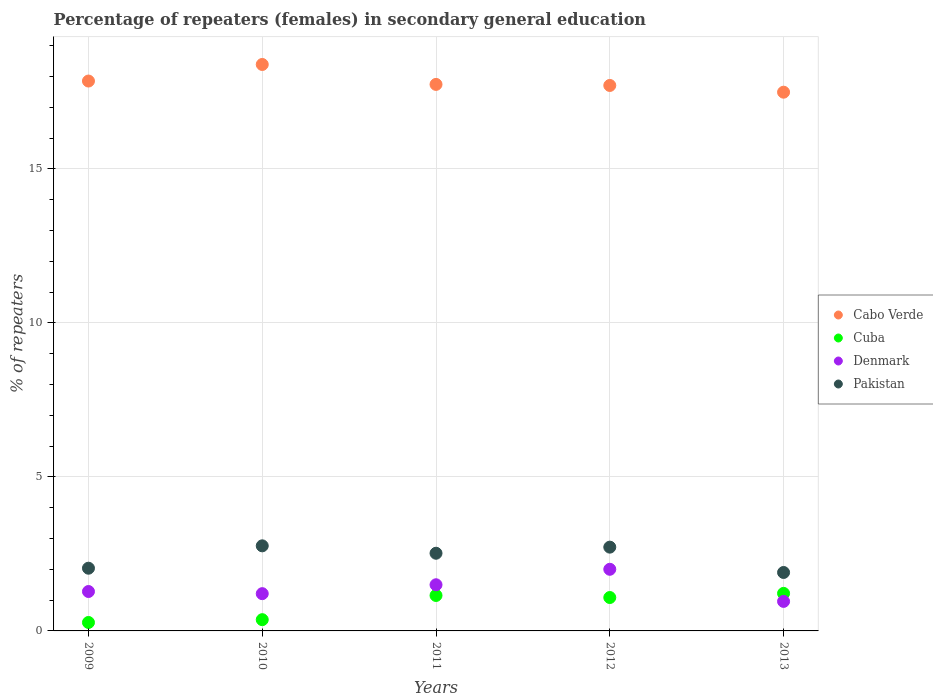Is the number of dotlines equal to the number of legend labels?
Ensure brevity in your answer.  Yes. What is the percentage of female repeaters in Cuba in 2011?
Provide a short and direct response. 1.15. Across all years, what is the maximum percentage of female repeaters in Cuba?
Give a very brief answer. 1.22. Across all years, what is the minimum percentage of female repeaters in Cabo Verde?
Make the answer very short. 17.49. In which year was the percentage of female repeaters in Denmark maximum?
Your answer should be very brief. 2012. In which year was the percentage of female repeaters in Cuba minimum?
Make the answer very short. 2009. What is the total percentage of female repeaters in Pakistan in the graph?
Your response must be concise. 11.94. What is the difference between the percentage of female repeaters in Pakistan in 2009 and that in 2012?
Your answer should be very brief. -0.68. What is the difference between the percentage of female repeaters in Cuba in 2013 and the percentage of female repeaters in Denmark in 2012?
Offer a very short reply. -0.78. What is the average percentage of female repeaters in Cuba per year?
Offer a very short reply. 0.82. In the year 2010, what is the difference between the percentage of female repeaters in Denmark and percentage of female repeaters in Pakistan?
Offer a terse response. -1.55. What is the ratio of the percentage of female repeaters in Cabo Verde in 2010 to that in 2011?
Make the answer very short. 1.04. What is the difference between the highest and the second highest percentage of female repeaters in Pakistan?
Give a very brief answer. 0.04. What is the difference between the highest and the lowest percentage of female repeaters in Cabo Verde?
Your answer should be very brief. 0.9. In how many years, is the percentage of female repeaters in Denmark greater than the average percentage of female repeaters in Denmark taken over all years?
Your answer should be compact. 2. Is it the case that in every year, the sum of the percentage of female repeaters in Cuba and percentage of female repeaters in Pakistan  is greater than the percentage of female repeaters in Cabo Verde?
Offer a terse response. No. Does the percentage of female repeaters in Pakistan monotonically increase over the years?
Your answer should be compact. No. How many dotlines are there?
Provide a short and direct response. 4. Does the graph contain any zero values?
Your answer should be compact. No. How are the legend labels stacked?
Make the answer very short. Vertical. What is the title of the graph?
Keep it short and to the point. Percentage of repeaters (females) in secondary general education. Does "Myanmar" appear as one of the legend labels in the graph?
Offer a terse response. No. What is the label or title of the X-axis?
Keep it short and to the point. Years. What is the label or title of the Y-axis?
Make the answer very short. % of repeaters. What is the % of repeaters in Cabo Verde in 2009?
Provide a succinct answer. 17.85. What is the % of repeaters of Cuba in 2009?
Your answer should be very brief. 0.27. What is the % of repeaters in Denmark in 2009?
Give a very brief answer. 1.28. What is the % of repeaters of Pakistan in 2009?
Your response must be concise. 2.04. What is the % of repeaters of Cabo Verde in 2010?
Your answer should be compact. 18.39. What is the % of repeaters in Cuba in 2010?
Offer a very short reply. 0.37. What is the % of repeaters in Denmark in 2010?
Offer a terse response. 1.21. What is the % of repeaters of Pakistan in 2010?
Your answer should be compact. 2.76. What is the % of repeaters of Cabo Verde in 2011?
Offer a terse response. 17.74. What is the % of repeaters in Cuba in 2011?
Keep it short and to the point. 1.15. What is the % of repeaters of Denmark in 2011?
Provide a short and direct response. 1.5. What is the % of repeaters of Pakistan in 2011?
Provide a short and direct response. 2.52. What is the % of repeaters of Cabo Verde in 2012?
Offer a terse response. 17.71. What is the % of repeaters in Cuba in 2012?
Your answer should be compact. 1.08. What is the % of repeaters in Denmark in 2012?
Keep it short and to the point. 2. What is the % of repeaters in Pakistan in 2012?
Give a very brief answer. 2.72. What is the % of repeaters in Cabo Verde in 2013?
Make the answer very short. 17.49. What is the % of repeaters of Cuba in 2013?
Keep it short and to the point. 1.22. What is the % of repeaters of Denmark in 2013?
Provide a short and direct response. 0.96. What is the % of repeaters of Pakistan in 2013?
Keep it short and to the point. 1.9. Across all years, what is the maximum % of repeaters of Cabo Verde?
Provide a succinct answer. 18.39. Across all years, what is the maximum % of repeaters of Cuba?
Give a very brief answer. 1.22. Across all years, what is the maximum % of repeaters in Denmark?
Provide a short and direct response. 2. Across all years, what is the maximum % of repeaters in Pakistan?
Provide a succinct answer. 2.76. Across all years, what is the minimum % of repeaters of Cabo Verde?
Offer a very short reply. 17.49. Across all years, what is the minimum % of repeaters in Cuba?
Offer a terse response. 0.27. Across all years, what is the minimum % of repeaters of Denmark?
Give a very brief answer. 0.96. Across all years, what is the minimum % of repeaters in Pakistan?
Keep it short and to the point. 1.9. What is the total % of repeaters in Cabo Verde in the graph?
Give a very brief answer. 89.18. What is the total % of repeaters of Cuba in the graph?
Ensure brevity in your answer.  4.09. What is the total % of repeaters in Denmark in the graph?
Offer a terse response. 6.95. What is the total % of repeaters in Pakistan in the graph?
Offer a very short reply. 11.94. What is the difference between the % of repeaters in Cabo Verde in 2009 and that in 2010?
Keep it short and to the point. -0.54. What is the difference between the % of repeaters of Cuba in 2009 and that in 2010?
Offer a terse response. -0.09. What is the difference between the % of repeaters in Denmark in 2009 and that in 2010?
Provide a short and direct response. 0.07. What is the difference between the % of repeaters of Pakistan in 2009 and that in 2010?
Your answer should be very brief. -0.73. What is the difference between the % of repeaters in Cabo Verde in 2009 and that in 2011?
Your answer should be very brief. 0.11. What is the difference between the % of repeaters in Cuba in 2009 and that in 2011?
Keep it short and to the point. -0.88. What is the difference between the % of repeaters of Denmark in 2009 and that in 2011?
Offer a very short reply. -0.22. What is the difference between the % of repeaters in Pakistan in 2009 and that in 2011?
Your answer should be very brief. -0.49. What is the difference between the % of repeaters of Cabo Verde in 2009 and that in 2012?
Offer a very short reply. 0.14. What is the difference between the % of repeaters in Cuba in 2009 and that in 2012?
Offer a very short reply. -0.81. What is the difference between the % of repeaters in Denmark in 2009 and that in 2012?
Provide a succinct answer. -0.72. What is the difference between the % of repeaters of Pakistan in 2009 and that in 2012?
Offer a terse response. -0.68. What is the difference between the % of repeaters of Cabo Verde in 2009 and that in 2013?
Your answer should be compact. 0.36. What is the difference between the % of repeaters in Cuba in 2009 and that in 2013?
Offer a very short reply. -0.94. What is the difference between the % of repeaters of Denmark in 2009 and that in 2013?
Provide a short and direct response. 0.32. What is the difference between the % of repeaters in Pakistan in 2009 and that in 2013?
Offer a terse response. 0.14. What is the difference between the % of repeaters of Cabo Verde in 2010 and that in 2011?
Provide a succinct answer. 0.65. What is the difference between the % of repeaters in Cuba in 2010 and that in 2011?
Your answer should be compact. -0.79. What is the difference between the % of repeaters of Denmark in 2010 and that in 2011?
Your response must be concise. -0.29. What is the difference between the % of repeaters in Pakistan in 2010 and that in 2011?
Offer a very short reply. 0.24. What is the difference between the % of repeaters of Cabo Verde in 2010 and that in 2012?
Make the answer very short. 0.68. What is the difference between the % of repeaters in Cuba in 2010 and that in 2012?
Offer a terse response. -0.72. What is the difference between the % of repeaters in Denmark in 2010 and that in 2012?
Ensure brevity in your answer.  -0.79. What is the difference between the % of repeaters in Pakistan in 2010 and that in 2012?
Offer a terse response. 0.04. What is the difference between the % of repeaters in Cabo Verde in 2010 and that in 2013?
Offer a very short reply. 0.9. What is the difference between the % of repeaters of Cuba in 2010 and that in 2013?
Provide a short and direct response. -0.85. What is the difference between the % of repeaters in Denmark in 2010 and that in 2013?
Offer a terse response. 0.25. What is the difference between the % of repeaters of Pakistan in 2010 and that in 2013?
Ensure brevity in your answer.  0.86. What is the difference between the % of repeaters of Cabo Verde in 2011 and that in 2012?
Offer a very short reply. 0.03. What is the difference between the % of repeaters in Cuba in 2011 and that in 2012?
Give a very brief answer. 0.07. What is the difference between the % of repeaters of Denmark in 2011 and that in 2012?
Keep it short and to the point. -0.5. What is the difference between the % of repeaters in Pakistan in 2011 and that in 2012?
Your answer should be very brief. -0.2. What is the difference between the % of repeaters in Cabo Verde in 2011 and that in 2013?
Provide a short and direct response. 0.25. What is the difference between the % of repeaters of Cuba in 2011 and that in 2013?
Make the answer very short. -0.07. What is the difference between the % of repeaters of Denmark in 2011 and that in 2013?
Offer a terse response. 0.54. What is the difference between the % of repeaters in Pakistan in 2011 and that in 2013?
Offer a very short reply. 0.62. What is the difference between the % of repeaters of Cabo Verde in 2012 and that in 2013?
Your answer should be very brief. 0.22. What is the difference between the % of repeaters in Cuba in 2012 and that in 2013?
Provide a succinct answer. -0.13. What is the difference between the % of repeaters of Denmark in 2012 and that in 2013?
Your answer should be compact. 1.04. What is the difference between the % of repeaters of Pakistan in 2012 and that in 2013?
Provide a short and direct response. 0.82. What is the difference between the % of repeaters in Cabo Verde in 2009 and the % of repeaters in Cuba in 2010?
Your answer should be compact. 17.49. What is the difference between the % of repeaters in Cabo Verde in 2009 and the % of repeaters in Denmark in 2010?
Your response must be concise. 16.64. What is the difference between the % of repeaters of Cabo Verde in 2009 and the % of repeaters of Pakistan in 2010?
Offer a terse response. 15.09. What is the difference between the % of repeaters of Cuba in 2009 and the % of repeaters of Denmark in 2010?
Ensure brevity in your answer.  -0.94. What is the difference between the % of repeaters of Cuba in 2009 and the % of repeaters of Pakistan in 2010?
Offer a very short reply. -2.49. What is the difference between the % of repeaters in Denmark in 2009 and the % of repeaters in Pakistan in 2010?
Ensure brevity in your answer.  -1.48. What is the difference between the % of repeaters of Cabo Verde in 2009 and the % of repeaters of Cuba in 2011?
Provide a short and direct response. 16.7. What is the difference between the % of repeaters in Cabo Verde in 2009 and the % of repeaters in Denmark in 2011?
Provide a succinct answer. 16.35. What is the difference between the % of repeaters of Cabo Verde in 2009 and the % of repeaters of Pakistan in 2011?
Provide a succinct answer. 15.33. What is the difference between the % of repeaters in Cuba in 2009 and the % of repeaters in Denmark in 2011?
Your answer should be compact. -1.22. What is the difference between the % of repeaters of Cuba in 2009 and the % of repeaters of Pakistan in 2011?
Offer a terse response. -2.25. What is the difference between the % of repeaters of Denmark in 2009 and the % of repeaters of Pakistan in 2011?
Offer a terse response. -1.24. What is the difference between the % of repeaters in Cabo Verde in 2009 and the % of repeaters in Cuba in 2012?
Your response must be concise. 16.77. What is the difference between the % of repeaters in Cabo Verde in 2009 and the % of repeaters in Denmark in 2012?
Keep it short and to the point. 15.85. What is the difference between the % of repeaters in Cabo Verde in 2009 and the % of repeaters in Pakistan in 2012?
Your response must be concise. 15.13. What is the difference between the % of repeaters in Cuba in 2009 and the % of repeaters in Denmark in 2012?
Offer a very short reply. -1.73. What is the difference between the % of repeaters of Cuba in 2009 and the % of repeaters of Pakistan in 2012?
Keep it short and to the point. -2.45. What is the difference between the % of repeaters in Denmark in 2009 and the % of repeaters in Pakistan in 2012?
Make the answer very short. -1.44. What is the difference between the % of repeaters of Cabo Verde in 2009 and the % of repeaters of Cuba in 2013?
Give a very brief answer. 16.63. What is the difference between the % of repeaters of Cabo Verde in 2009 and the % of repeaters of Denmark in 2013?
Provide a succinct answer. 16.89. What is the difference between the % of repeaters in Cabo Verde in 2009 and the % of repeaters in Pakistan in 2013?
Your answer should be very brief. 15.95. What is the difference between the % of repeaters of Cuba in 2009 and the % of repeaters of Denmark in 2013?
Provide a short and direct response. -0.68. What is the difference between the % of repeaters in Cuba in 2009 and the % of repeaters in Pakistan in 2013?
Keep it short and to the point. -1.62. What is the difference between the % of repeaters of Denmark in 2009 and the % of repeaters of Pakistan in 2013?
Your answer should be very brief. -0.62. What is the difference between the % of repeaters in Cabo Verde in 2010 and the % of repeaters in Cuba in 2011?
Make the answer very short. 17.24. What is the difference between the % of repeaters of Cabo Verde in 2010 and the % of repeaters of Denmark in 2011?
Give a very brief answer. 16.89. What is the difference between the % of repeaters of Cabo Verde in 2010 and the % of repeaters of Pakistan in 2011?
Offer a terse response. 15.87. What is the difference between the % of repeaters of Cuba in 2010 and the % of repeaters of Denmark in 2011?
Your answer should be compact. -1.13. What is the difference between the % of repeaters in Cuba in 2010 and the % of repeaters in Pakistan in 2011?
Ensure brevity in your answer.  -2.16. What is the difference between the % of repeaters in Denmark in 2010 and the % of repeaters in Pakistan in 2011?
Provide a succinct answer. -1.31. What is the difference between the % of repeaters of Cabo Verde in 2010 and the % of repeaters of Cuba in 2012?
Keep it short and to the point. 17.3. What is the difference between the % of repeaters of Cabo Verde in 2010 and the % of repeaters of Denmark in 2012?
Your answer should be compact. 16.39. What is the difference between the % of repeaters of Cabo Verde in 2010 and the % of repeaters of Pakistan in 2012?
Provide a succinct answer. 15.67. What is the difference between the % of repeaters in Cuba in 2010 and the % of repeaters in Denmark in 2012?
Your answer should be compact. -1.64. What is the difference between the % of repeaters of Cuba in 2010 and the % of repeaters of Pakistan in 2012?
Provide a short and direct response. -2.35. What is the difference between the % of repeaters in Denmark in 2010 and the % of repeaters in Pakistan in 2012?
Your answer should be compact. -1.51. What is the difference between the % of repeaters of Cabo Verde in 2010 and the % of repeaters of Cuba in 2013?
Your answer should be very brief. 17.17. What is the difference between the % of repeaters in Cabo Verde in 2010 and the % of repeaters in Denmark in 2013?
Offer a terse response. 17.43. What is the difference between the % of repeaters of Cabo Verde in 2010 and the % of repeaters of Pakistan in 2013?
Your answer should be very brief. 16.49. What is the difference between the % of repeaters in Cuba in 2010 and the % of repeaters in Denmark in 2013?
Keep it short and to the point. -0.59. What is the difference between the % of repeaters of Cuba in 2010 and the % of repeaters of Pakistan in 2013?
Offer a terse response. -1.53. What is the difference between the % of repeaters in Denmark in 2010 and the % of repeaters in Pakistan in 2013?
Offer a very short reply. -0.69. What is the difference between the % of repeaters of Cabo Verde in 2011 and the % of repeaters of Cuba in 2012?
Your answer should be very brief. 16.66. What is the difference between the % of repeaters in Cabo Verde in 2011 and the % of repeaters in Denmark in 2012?
Provide a short and direct response. 15.74. What is the difference between the % of repeaters of Cabo Verde in 2011 and the % of repeaters of Pakistan in 2012?
Ensure brevity in your answer.  15.02. What is the difference between the % of repeaters of Cuba in 2011 and the % of repeaters of Denmark in 2012?
Offer a terse response. -0.85. What is the difference between the % of repeaters of Cuba in 2011 and the % of repeaters of Pakistan in 2012?
Keep it short and to the point. -1.57. What is the difference between the % of repeaters of Denmark in 2011 and the % of repeaters of Pakistan in 2012?
Your response must be concise. -1.22. What is the difference between the % of repeaters of Cabo Verde in 2011 and the % of repeaters of Cuba in 2013?
Provide a short and direct response. 16.52. What is the difference between the % of repeaters of Cabo Verde in 2011 and the % of repeaters of Denmark in 2013?
Your response must be concise. 16.78. What is the difference between the % of repeaters in Cabo Verde in 2011 and the % of repeaters in Pakistan in 2013?
Keep it short and to the point. 15.84. What is the difference between the % of repeaters in Cuba in 2011 and the % of repeaters in Denmark in 2013?
Give a very brief answer. 0.19. What is the difference between the % of repeaters in Cuba in 2011 and the % of repeaters in Pakistan in 2013?
Keep it short and to the point. -0.75. What is the difference between the % of repeaters in Denmark in 2011 and the % of repeaters in Pakistan in 2013?
Keep it short and to the point. -0.4. What is the difference between the % of repeaters of Cabo Verde in 2012 and the % of repeaters of Cuba in 2013?
Keep it short and to the point. 16.49. What is the difference between the % of repeaters of Cabo Verde in 2012 and the % of repeaters of Denmark in 2013?
Provide a short and direct response. 16.75. What is the difference between the % of repeaters of Cabo Verde in 2012 and the % of repeaters of Pakistan in 2013?
Ensure brevity in your answer.  15.81. What is the difference between the % of repeaters in Cuba in 2012 and the % of repeaters in Denmark in 2013?
Your response must be concise. 0.13. What is the difference between the % of repeaters in Cuba in 2012 and the % of repeaters in Pakistan in 2013?
Your answer should be compact. -0.81. What is the difference between the % of repeaters in Denmark in 2012 and the % of repeaters in Pakistan in 2013?
Offer a very short reply. 0.1. What is the average % of repeaters of Cabo Verde per year?
Your answer should be very brief. 17.84. What is the average % of repeaters of Cuba per year?
Give a very brief answer. 0.82. What is the average % of repeaters of Denmark per year?
Offer a very short reply. 1.39. What is the average % of repeaters in Pakistan per year?
Provide a short and direct response. 2.39. In the year 2009, what is the difference between the % of repeaters of Cabo Verde and % of repeaters of Cuba?
Your answer should be compact. 17.58. In the year 2009, what is the difference between the % of repeaters in Cabo Verde and % of repeaters in Denmark?
Provide a short and direct response. 16.57. In the year 2009, what is the difference between the % of repeaters of Cabo Verde and % of repeaters of Pakistan?
Provide a short and direct response. 15.81. In the year 2009, what is the difference between the % of repeaters in Cuba and % of repeaters in Denmark?
Your answer should be very brief. -1. In the year 2009, what is the difference between the % of repeaters of Cuba and % of repeaters of Pakistan?
Give a very brief answer. -1.76. In the year 2009, what is the difference between the % of repeaters in Denmark and % of repeaters in Pakistan?
Make the answer very short. -0.76. In the year 2010, what is the difference between the % of repeaters of Cabo Verde and % of repeaters of Cuba?
Offer a terse response. 18.02. In the year 2010, what is the difference between the % of repeaters of Cabo Verde and % of repeaters of Denmark?
Keep it short and to the point. 17.18. In the year 2010, what is the difference between the % of repeaters of Cabo Verde and % of repeaters of Pakistan?
Offer a very short reply. 15.63. In the year 2010, what is the difference between the % of repeaters in Cuba and % of repeaters in Denmark?
Offer a very short reply. -0.84. In the year 2010, what is the difference between the % of repeaters in Cuba and % of repeaters in Pakistan?
Make the answer very short. -2.4. In the year 2010, what is the difference between the % of repeaters of Denmark and % of repeaters of Pakistan?
Ensure brevity in your answer.  -1.55. In the year 2011, what is the difference between the % of repeaters of Cabo Verde and % of repeaters of Cuba?
Give a very brief answer. 16.59. In the year 2011, what is the difference between the % of repeaters in Cabo Verde and % of repeaters in Denmark?
Give a very brief answer. 16.24. In the year 2011, what is the difference between the % of repeaters of Cabo Verde and % of repeaters of Pakistan?
Give a very brief answer. 15.22. In the year 2011, what is the difference between the % of repeaters in Cuba and % of repeaters in Denmark?
Offer a terse response. -0.35. In the year 2011, what is the difference between the % of repeaters of Cuba and % of repeaters of Pakistan?
Provide a succinct answer. -1.37. In the year 2011, what is the difference between the % of repeaters of Denmark and % of repeaters of Pakistan?
Give a very brief answer. -1.02. In the year 2012, what is the difference between the % of repeaters of Cabo Verde and % of repeaters of Cuba?
Give a very brief answer. 16.62. In the year 2012, what is the difference between the % of repeaters of Cabo Verde and % of repeaters of Denmark?
Your response must be concise. 15.71. In the year 2012, what is the difference between the % of repeaters in Cabo Verde and % of repeaters in Pakistan?
Make the answer very short. 14.99. In the year 2012, what is the difference between the % of repeaters in Cuba and % of repeaters in Denmark?
Your answer should be compact. -0.92. In the year 2012, what is the difference between the % of repeaters of Cuba and % of repeaters of Pakistan?
Make the answer very short. -1.64. In the year 2012, what is the difference between the % of repeaters of Denmark and % of repeaters of Pakistan?
Offer a terse response. -0.72. In the year 2013, what is the difference between the % of repeaters of Cabo Verde and % of repeaters of Cuba?
Ensure brevity in your answer.  16.27. In the year 2013, what is the difference between the % of repeaters of Cabo Verde and % of repeaters of Denmark?
Ensure brevity in your answer.  16.53. In the year 2013, what is the difference between the % of repeaters of Cabo Verde and % of repeaters of Pakistan?
Your answer should be very brief. 15.59. In the year 2013, what is the difference between the % of repeaters in Cuba and % of repeaters in Denmark?
Offer a terse response. 0.26. In the year 2013, what is the difference between the % of repeaters in Cuba and % of repeaters in Pakistan?
Offer a terse response. -0.68. In the year 2013, what is the difference between the % of repeaters in Denmark and % of repeaters in Pakistan?
Offer a very short reply. -0.94. What is the ratio of the % of repeaters of Cabo Verde in 2009 to that in 2010?
Your answer should be compact. 0.97. What is the ratio of the % of repeaters in Cuba in 2009 to that in 2010?
Provide a short and direct response. 0.75. What is the ratio of the % of repeaters in Denmark in 2009 to that in 2010?
Provide a short and direct response. 1.06. What is the ratio of the % of repeaters in Pakistan in 2009 to that in 2010?
Your answer should be very brief. 0.74. What is the ratio of the % of repeaters of Cuba in 2009 to that in 2011?
Your answer should be very brief. 0.24. What is the ratio of the % of repeaters of Denmark in 2009 to that in 2011?
Provide a short and direct response. 0.85. What is the ratio of the % of repeaters of Pakistan in 2009 to that in 2011?
Your answer should be compact. 0.81. What is the ratio of the % of repeaters in Cuba in 2009 to that in 2012?
Offer a very short reply. 0.25. What is the ratio of the % of repeaters in Denmark in 2009 to that in 2012?
Offer a very short reply. 0.64. What is the ratio of the % of repeaters in Pakistan in 2009 to that in 2012?
Provide a short and direct response. 0.75. What is the ratio of the % of repeaters in Cabo Verde in 2009 to that in 2013?
Your answer should be compact. 1.02. What is the ratio of the % of repeaters in Cuba in 2009 to that in 2013?
Your answer should be very brief. 0.23. What is the ratio of the % of repeaters of Denmark in 2009 to that in 2013?
Offer a very short reply. 1.33. What is the ratio of the % of repeaters of Pakistan in 2009 to that in 2013?
Your response must be concise. 1.07. What is the ratio of the % of repeaters of Cabo Verde in 2010 to that in 2011?
Provide a short and direct response. 1.04. What is the ratio of the % of repeaters in Cuba in 2010 to that in 2011?
Give a very brief answer. 0.32. What is the ratio of the % of repeaters in Denmark in 2010 to that in 2011?
Ensure brevity in your answer.  0.81. What is the ratio of the % of repeaters of Pakistan in 2010 to that in 2011?
Offer a very short reply. 1.1. What is the ratio of the % of repeaters of Cuba in 2010 to that in 2012?
Offer a terse response. 0.34. What is the ratio of the % of repeaters in Denmark in 2010 to that in 2012?
Offer a very short reply. 0.6. What is the ratio of the % of repeaters in Pakistan in 2010 to that in 2012?
Offer a very short reply. 1.02. What is the ratio of the % of repeaters of Cabo Verde in 2010 to that in 2013?
Provide a succinct answer. 1.05. What is the ratio of the % of repeaters of Cuba in 2010 to that in 2013?
Your response must be concise. 0.3. What is the ratio of the % of repeaters in Denmark in 2010 to that in 2013?
Offer a terse response. 1.26. What is the ratio of the % of repeaters of Pakistan in 2010 to that in 2013?
Your answer should be very brief. 1.46. What is the ratio of the % of repeaters in Cuba in 2011 to that in 2012?
Offer a terse response. 1.06. What is the ratio of the % of repeaters of Denmark in 2011 to that in 2012?
Your answer should be compact. 0.75. What is the ratio of the % of repeaters of Pakistan in 2011 to that in 2012?
Your answer should be compact. 0.93. What is the ratio of the % of repeaters of Cabo Verde in 2011 to that in 2013?
Provide a succinct answer. 1.01. What is the ratio of the % of repeaters in Cuba in 2011 to that in 2013?
Your answer should be very brief. 0.94. What is the ratio of the % of repeaters of Denmark in 2011 to that in 2013?
Your response must be concise. 1.56. What is the ratio of the % of repeaters in Pakistan in 2011 to that in 2013?
Your answer should be compact. 1.33. What is the ratio of the % of repeaters in Cabo Verde in 2012 to that in 2013?
Keep it short and to the point. 1.01. What is the ratio of the % of repeaters of Cuba in 2012 to that in 2013?
Ensure brevity in your answer.  0.89. What is the ratio of the % of repeaters of Denmark in 2012 to that in 2013?
Provide a succinct answer. 2.09. What is the ratio of the % of repeaters of Pakistan in 2012 to that in 2013?
Provide a short and direct response. 1.43. What is the difference between the highest and the second highest % of repeaters in Cabo Verde?
Give a very brief answer. 0.54. What is the difference between the highest and the second highest % of repeaters of Cuba?
Provide a short and direct response. 0.07. What is the difference between the highest and the second highest % of repeaters in Denmark?
Make the answer very short. 0.5. What is the difference between the highest and the second highest % of repeaters in Pakistan?
Offer a very short reply. 0.04. What is the difference between the highest and the lowest % of repeaters of Cabo Verde?
Ensure brevity in your answer.  0.9. What is the difference between the highest and the lowest % of repeaters in Cuba?
Offer a terse response. 0.94. What is the difference between the highest and the lowest % of repeaters of Denmark?
Offer a terse response. 1.04. What is the difference between the highest and the lowest % of repeaters in Pakistan?
Give a very brief answer. 0.86. 